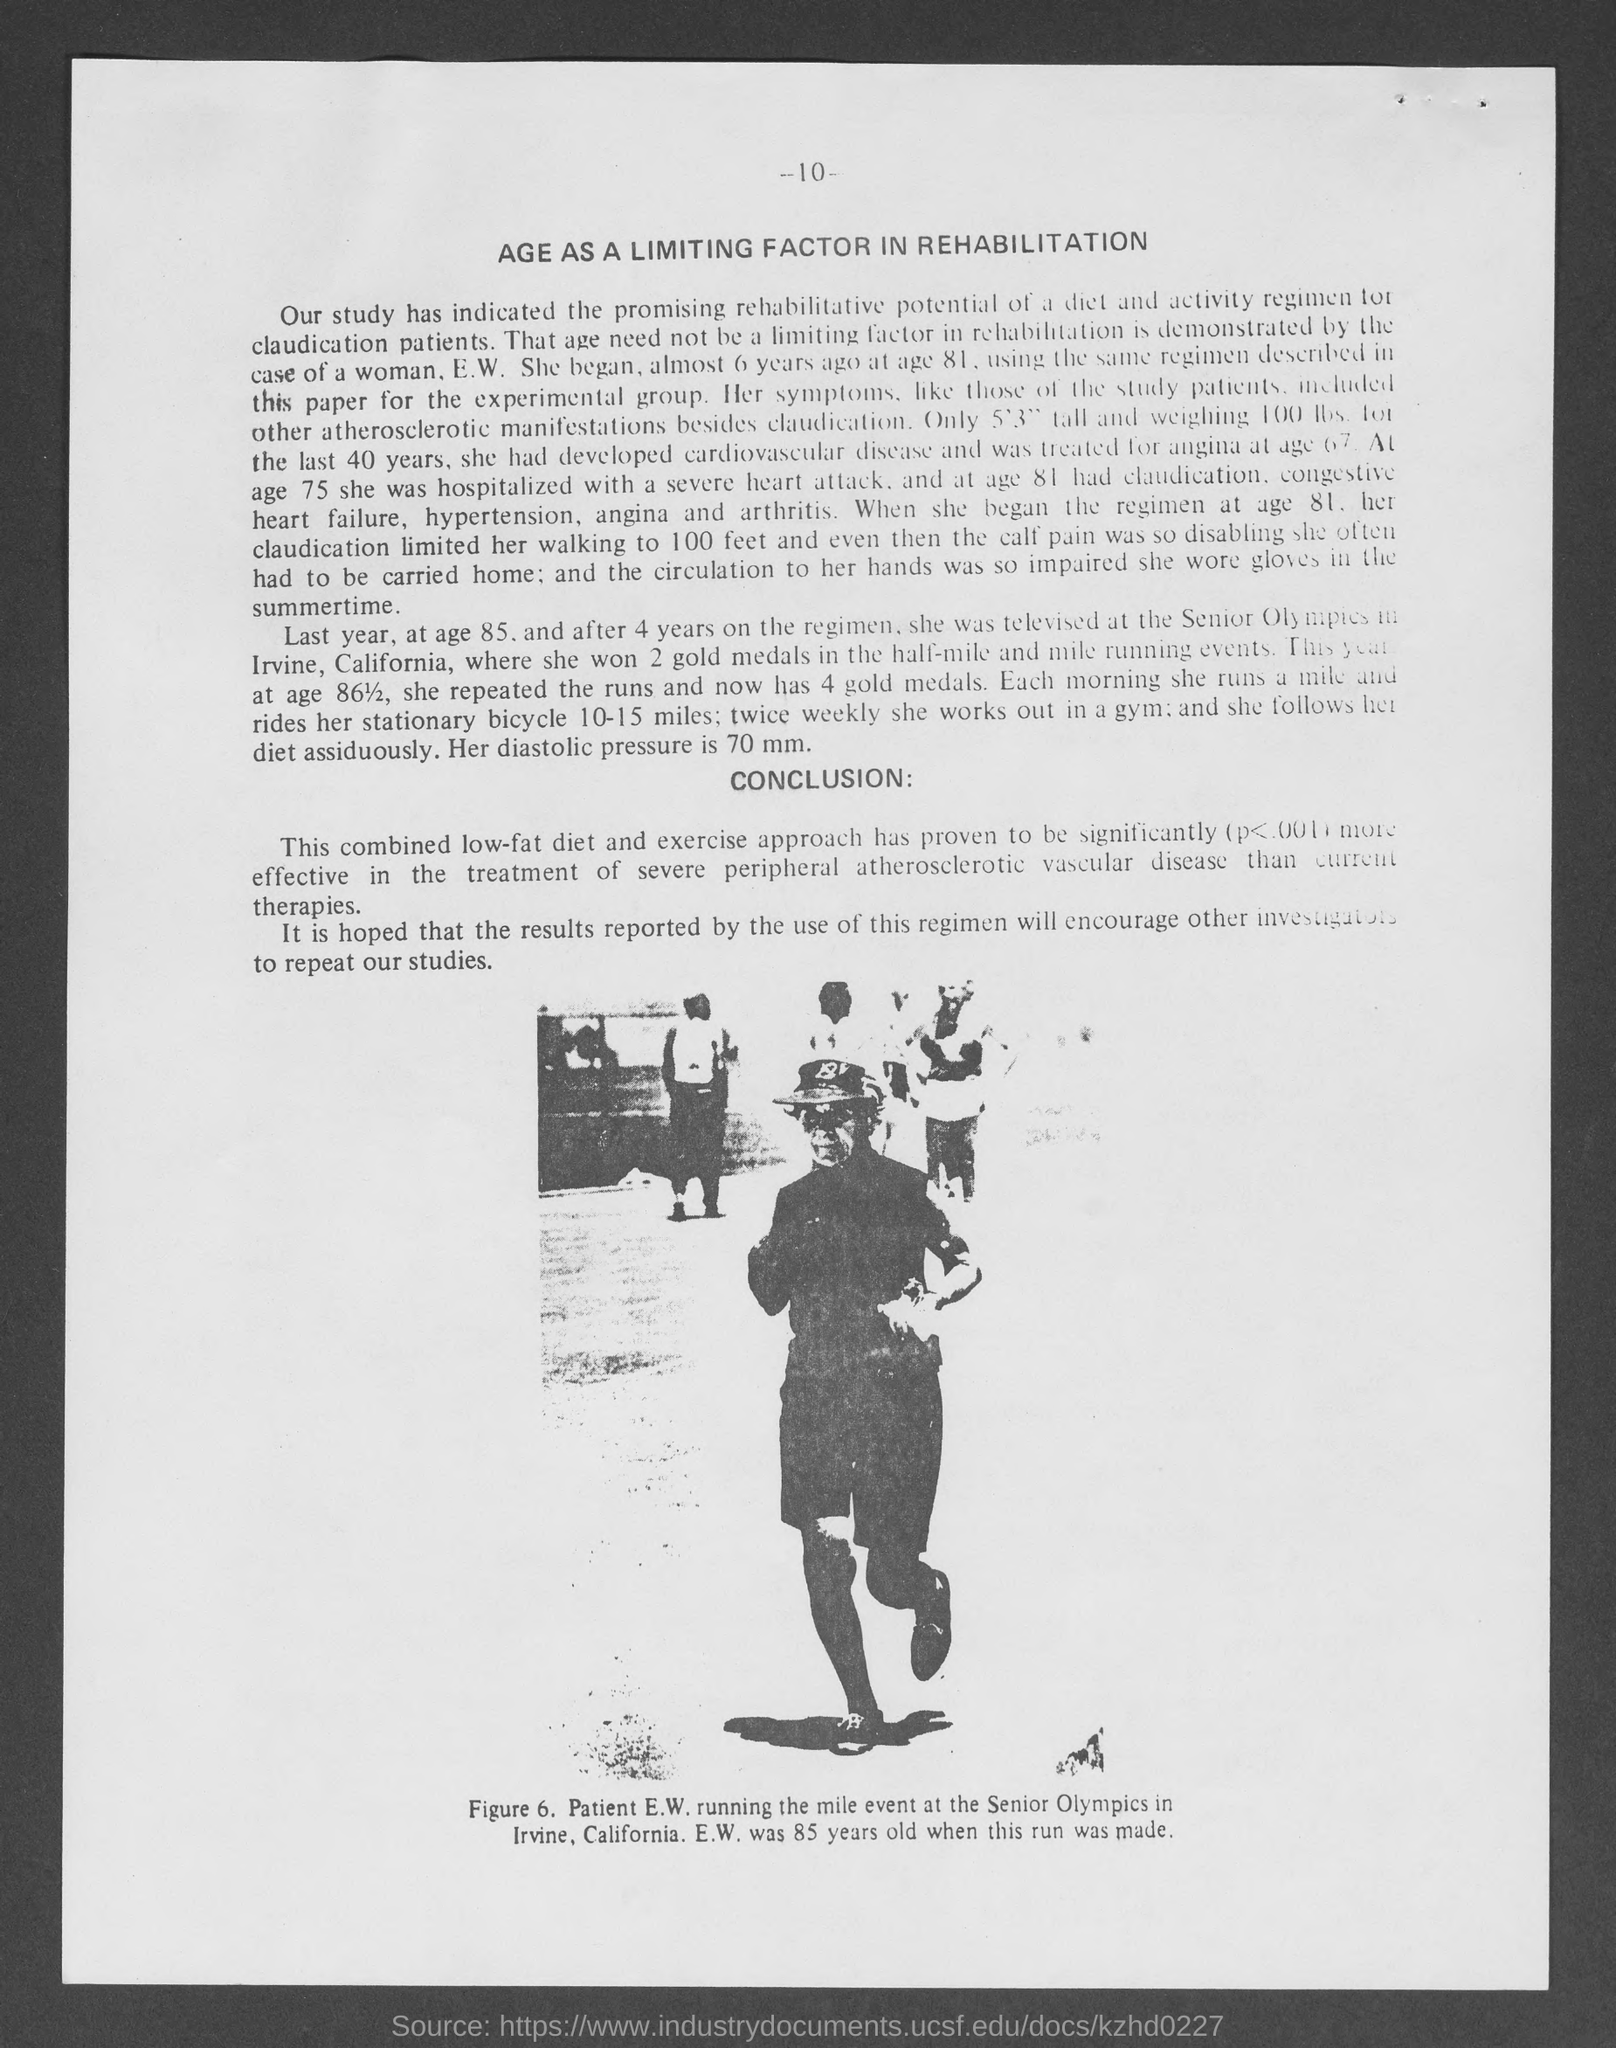Highlight a few significant elements in this photo. The combined approach of a low-fat diet and exercise has been proven to be a highly effective treatment for severe peripheral atherosclerotic vascular disease. The patient's picture is shown, and the patient's name is Patient E.W. She won two gold medals at the age of 85. The page number located at the top of the page is 10. The Senior Olympics was held in Irvine, California. 